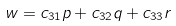Convert formula to latex. <formula><loc_0><loc_0><loc_500><loc_500>w = c _ { 3 1 } p + c _ { 3 2 } q + c _ { 3 3 } r</formula> 